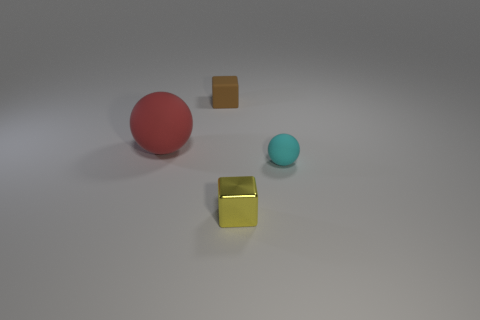Can you describe the different shapes and their colors in this image? Certainly! In this image, there are two spheres and two cubes. The spheres include one red and one blue. As for the cubes, one is brown and another cube that has a metallic or shiny gold appearance. 